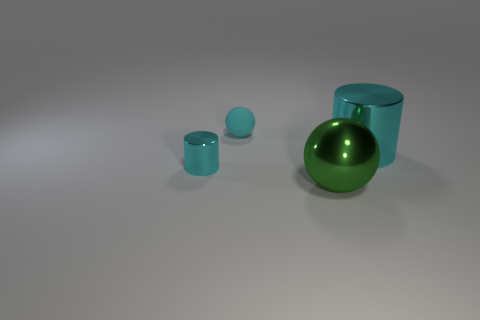Add 2 big metallic spheres. How many objects exist? 6 Add 2 tiny matte objects. How many tiny matte objects are left? 3 Add 4 tiny spheres. How many tiny spheres exist? 5 Subtract 0 green cylinders. How many objects are left? 4 Subtract all large green objects. Subtract all metal objects. How many objects are left? 0 